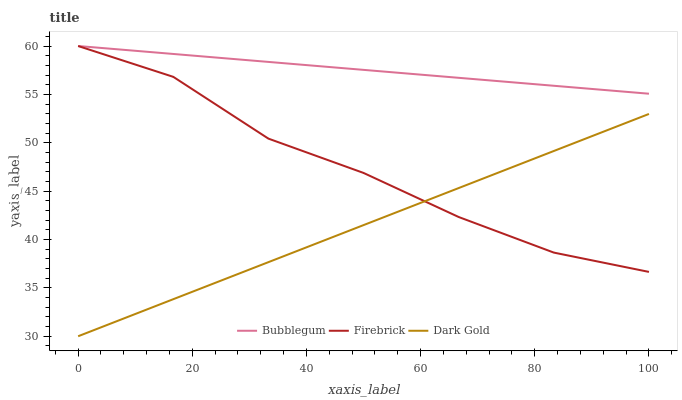Does Bubblegum have the minimum area under the curve?
Answer yes or no. No. Does Dark Gold have the maximum area under the curve?
Answer yes or no. No. Is Bubblegum the smoothest?
Answer yes or no. No. Is Bubblegum the roughest?
Answer yes or no. No. Does Bubblegum have the lowest value?
Answer yes or no. No. Does Dark Gold have the highest value?
Answer yes or no. No. Is Dark Gold less than Bubblegum?
Answer yes or no. Yes. Is Bubblegum greater than Dark Gold?
Answer yes or no. Yes. Does Dark Gold intersect Bubblegum?
Answer yes or no. No. 